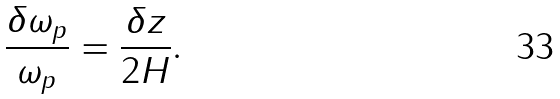Convert formula to latex. <formula><loc_0><loc_0><loc_500><loc_500>\frac { \delta \omega _ { p } } { \omega _ { p } } = \frac { \delta z } { 2 H } .</formula> 